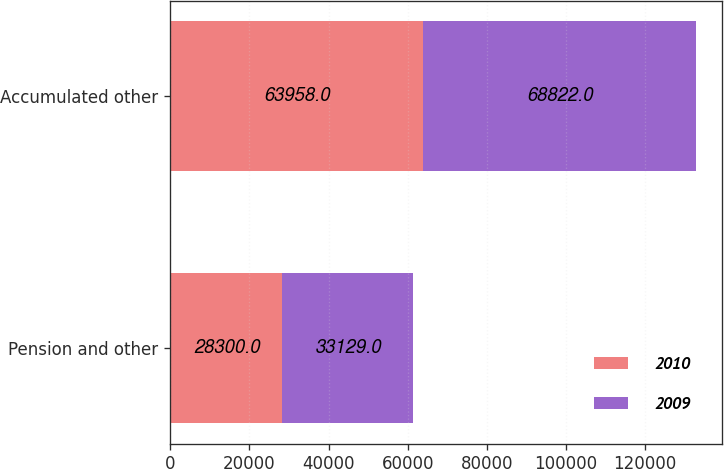<chart> <loc_0><loc_0><loc_500><loc_500><stacked_bar_chart><ecel><fcel>Pension and other<fcel>Accumulated other<nl><fcel>2010<fcel>28300<fcel>63958<nl><fcel>2009<fcel>33129<fcel>68822<nl></chart> 